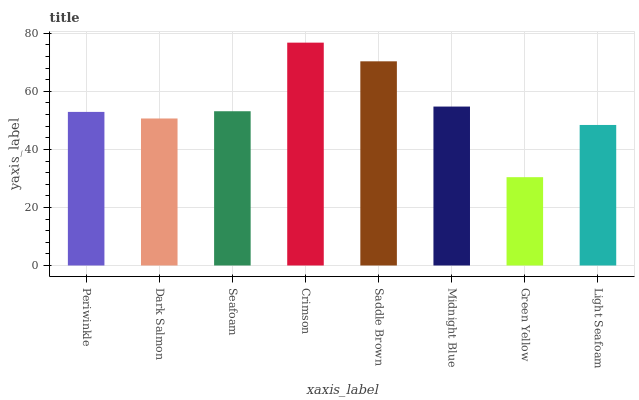Is Green Yellow the minimum?
Answer yes or no. Yes. Is Crimson the maximum?
Answer yes or no. Yes. Is Dark Salmon the minimum?
Answer yes or no. No. Is Dark Salmon the maximum?
Answer yes or no. No. Is Periwinkle greater than Dark Salmon?
Answer yes or no. Yes. Is Dark Salmon less than Periwinkle?
Answer yes or no. Yes. Is Dark Salmon greater than Periwinkle?
Answer yes or no. No. Is Periwinkle less than Dark Salmon?
Answer yes or no. No. Is Seafoam the high median?
Answer yes or no. Yes. Is Periwinkle the low median?
Answer yes or no. Yes. Is Dark Salmon the high median?
Answer yes or no. No. Is Saddle Brown the low median?
Answer yes or no. No. 